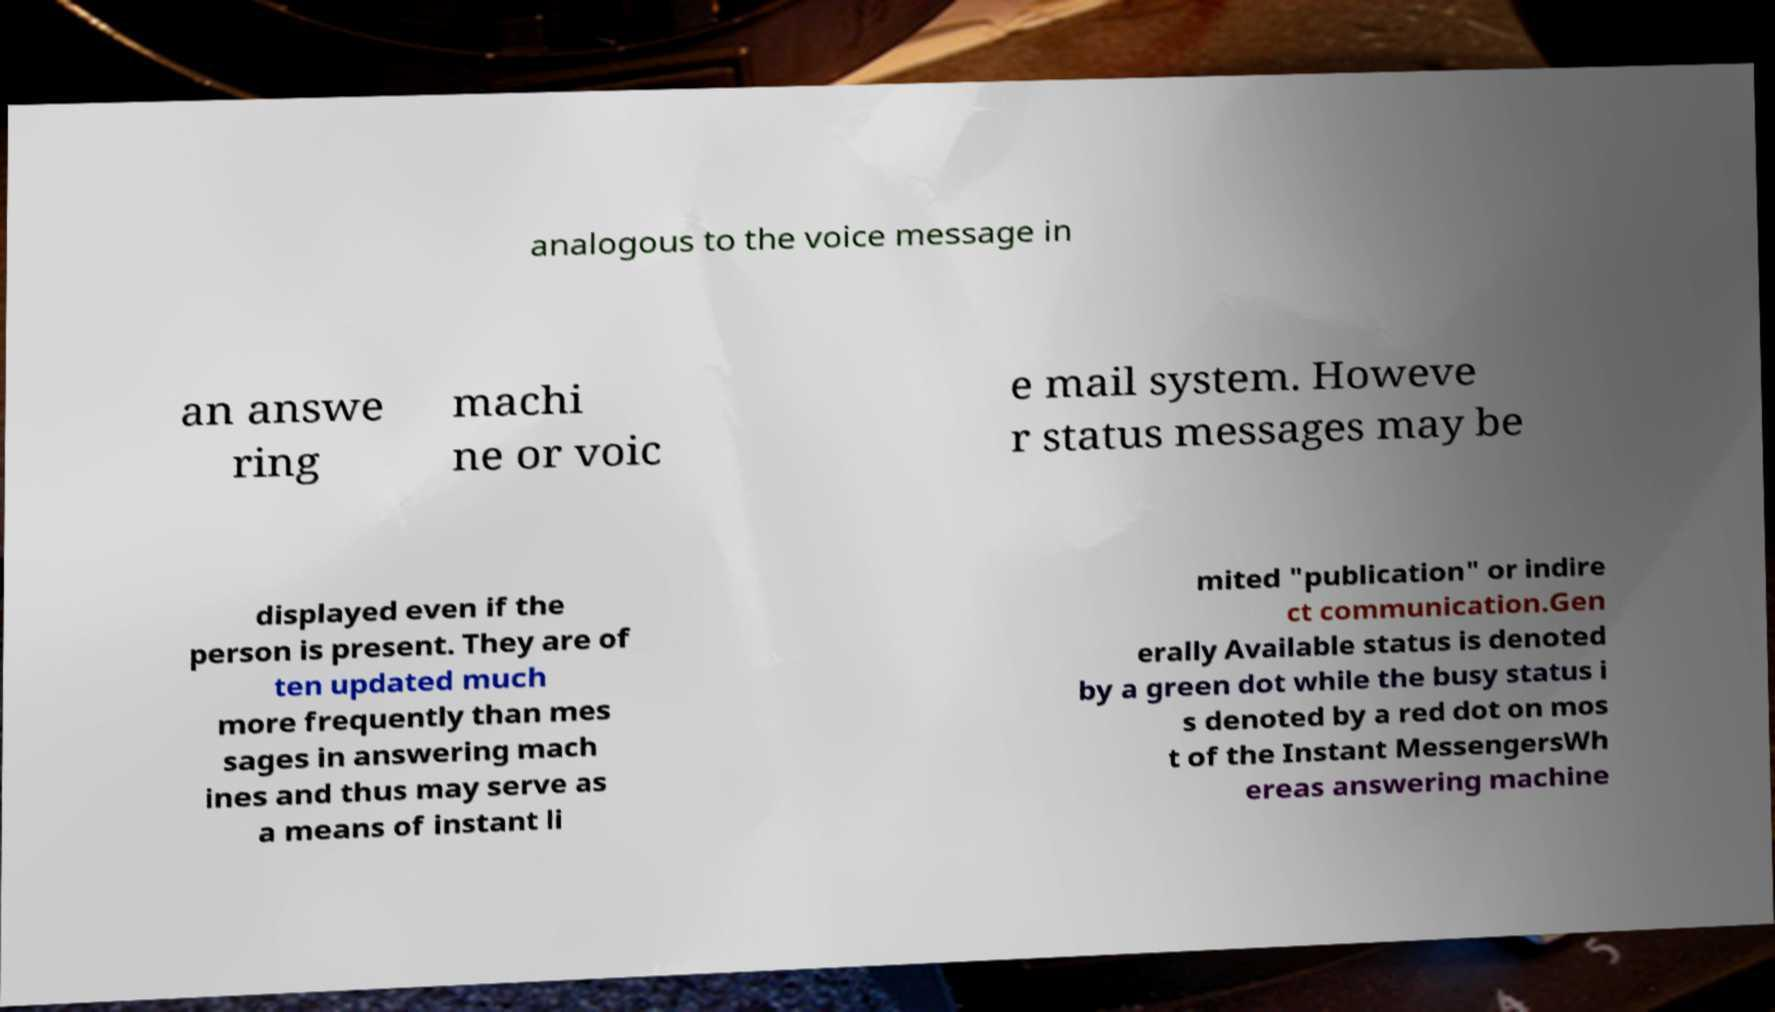Please identify and transcribe the text found in this image. analogous to the voice message in an answe ring machi ne or voic e mail system. Howeve r status messages may be displayed even if the person is present. They are of ten updated much more frequently than mes sages in answering mach ines and thus may serve as a means of instant li mited "publication" or indire ct communication.Gen erally Available status is denoted by a green dot while the busy status i s denoted by a red dot on mos t of the Instant MessengersWh ereas answering machine 